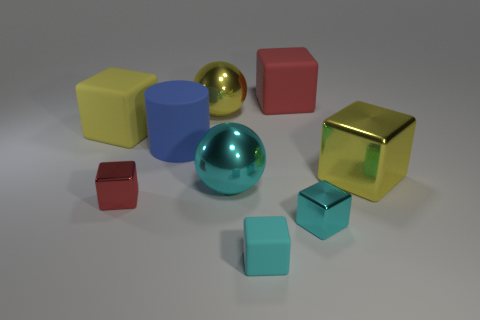Subtract all red cubes. How many were subtracted if there are1red cubes left? 1 Subtract all yellow cubes. How many cubes are left? 4 Subtract 2 cyan blocks. How many objects are left? 7 Subtract all balls. How many objects are left? 7 Subtract 6 cubes. How many cubes are left? 0 Subtract all blue spheres. Subtract all cyan blocks. How many spheres are left? 2 Subtract all gray cubes. How many yellow balls are left? 1 Subtract all green objects. Subtract all matte objects. How many objects are left? 5 Add 7 cyan metallic objects. How many cyan metallic objects are left? 9 Add 1 large cyan shiny things. How many large cyan shiny things exist? 2 